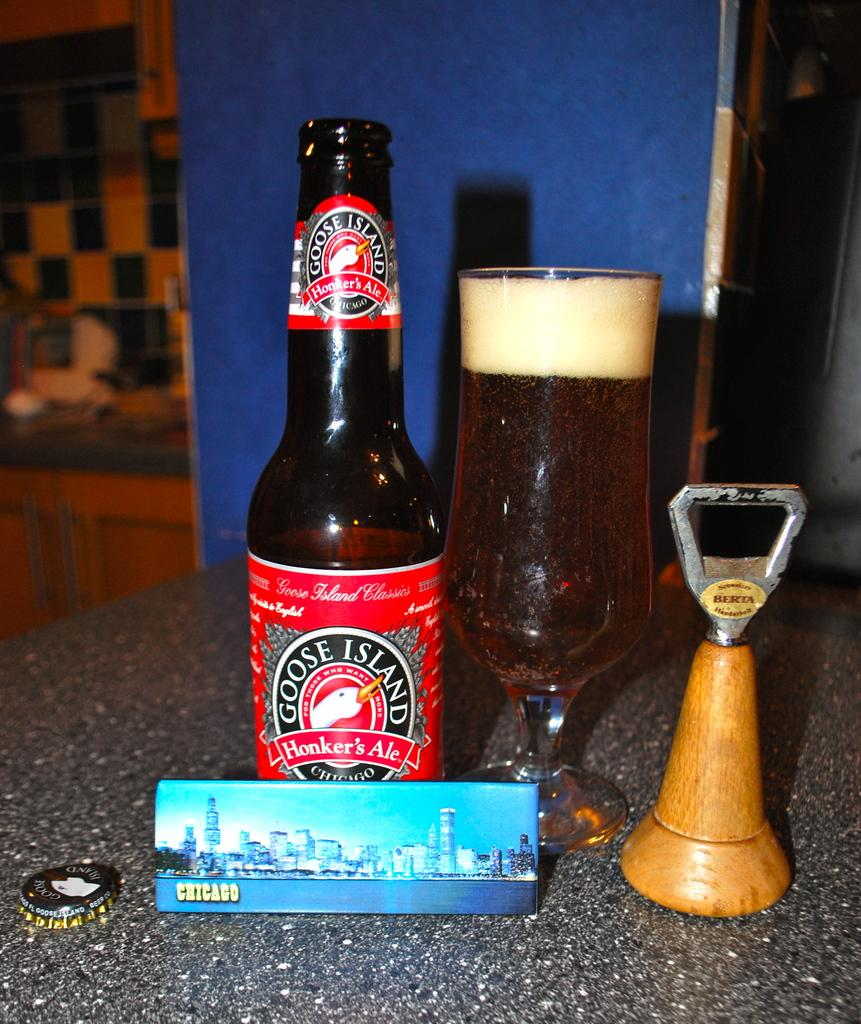<image>
Summarize the visual content of the image. Bottle of Goose Island HOnker's Ale beside a full glass. 